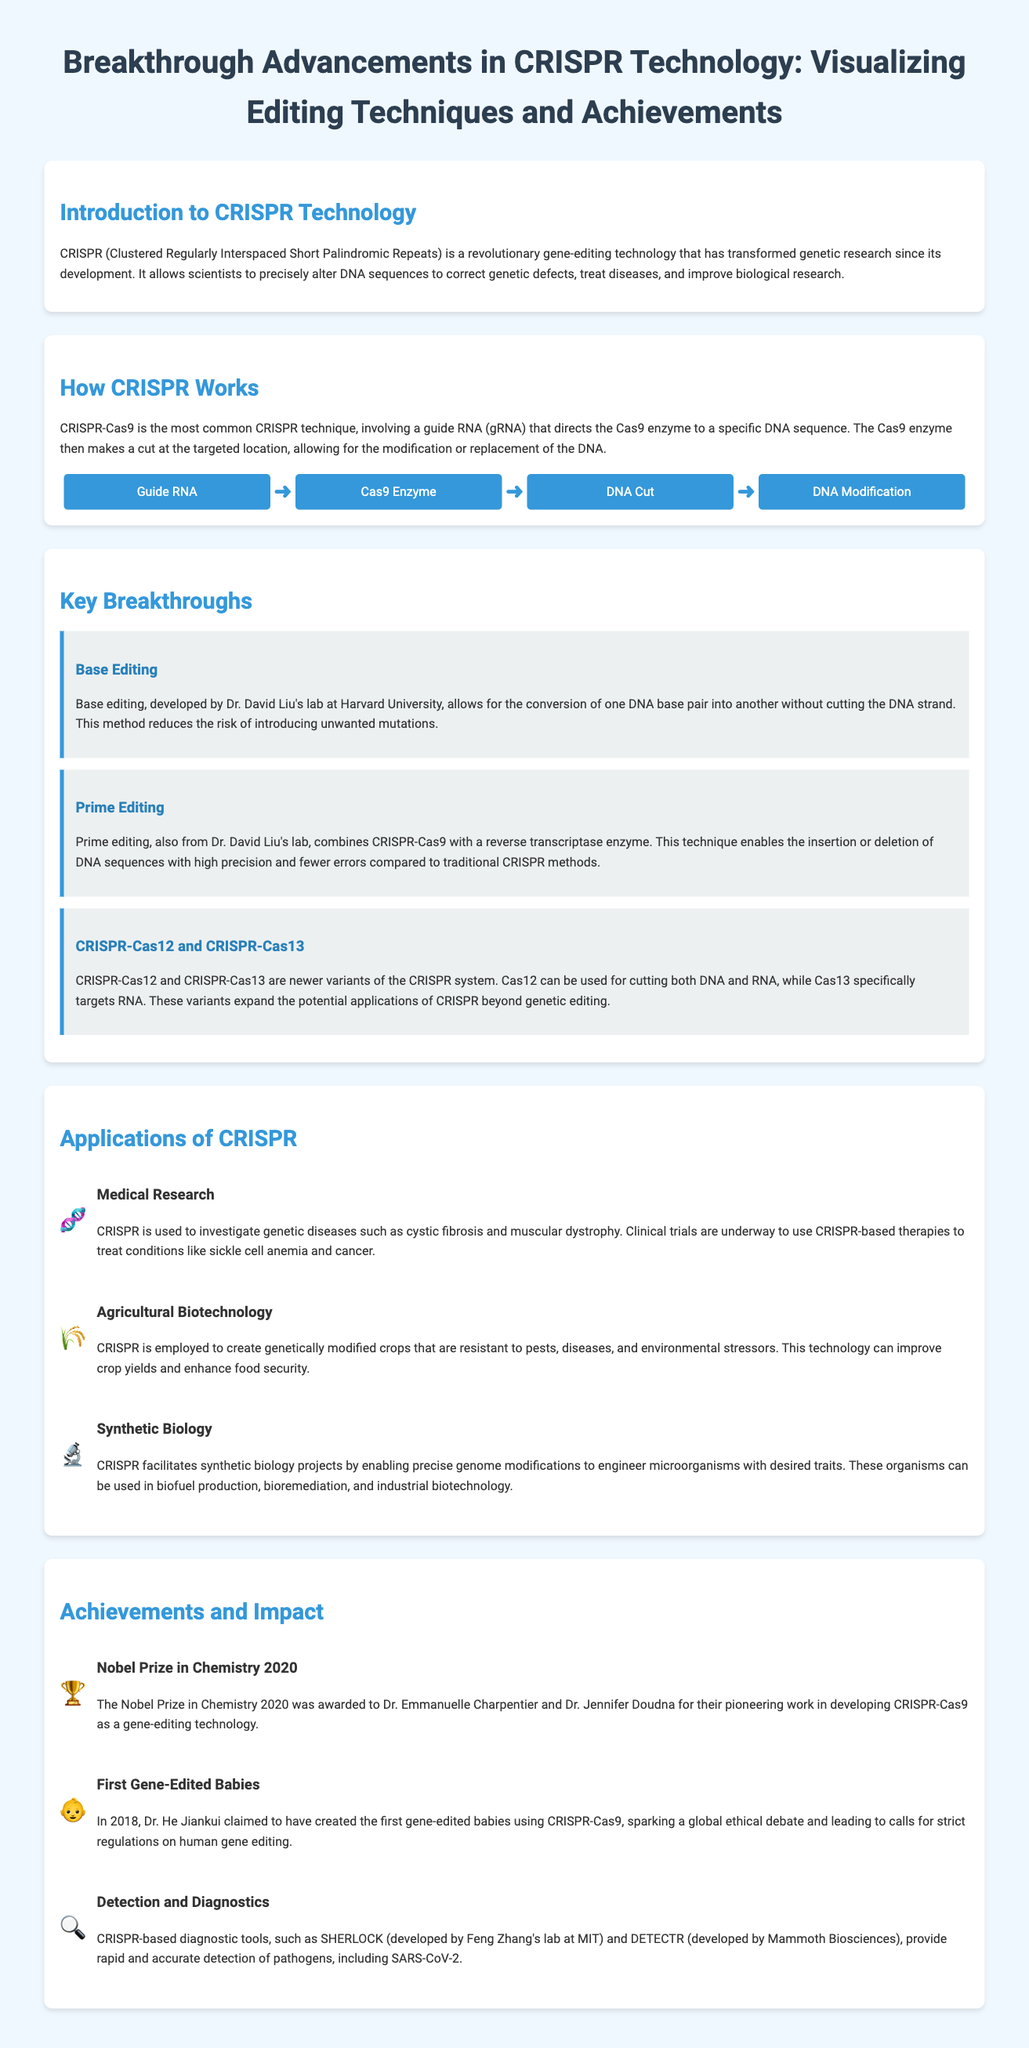What does CRISPR stand for? The document provides the full form of CRISPR in the introduction section, which is "Clustered Regularly Interspaced Short Palindromic Repeats."
Answer: Clustered Regularly Interspaced Short Palindromic Repeats Who developed base editing? The document states that base editing was developed by Dr. David Liu's lab at Harvard University.
Answer: Dr. David Liu What is the main advantage of base editing? The document mentions that base editing allows for the conversion of one DNA base pair into another without cutting the DNA strand, reducing the risk of mutations.
Answer: Reduces the risk of unwanted mutations What year was the Nobel Prize in Chemistry awarded for CRISPR-Cas9? The document states that the Nobel Prize in Chemistry was awarded in 2020 for the CRISPR-Cas9 development.
Answer: 2020 What technique combines CRISPR-Cas9 with a reverse transcriptase enzyme? The document refers to a new technique as "Prime editing."
Answer: Prime editing Which crop-related application does CRISPR technology facilitate? The document indicates that CRISPR is employed to create genetically modified crops resistant to pests and diseases.
Answer: Genetically modified crops What sparked a global ethical debate regarding gene editing? The document highlights that the creation of the first gene-edited babies claimed by Dr. He Jiankui in 2018 initiated this debate.
Answer: Gene-edited babies What is SHERLOCK? The document describes SHERLOCK as a CRISPR-based diagnostic tool for detecting pathogens.
Answer: A diagnostic tool How does the flow chart illustrate CRISPR's functioning? The flow chart visually represents the sequence of steps: Guide RNA ➜ Cas9 Enzyme ➜ DNA Cut ➜ DNA Modification.
Answer: Guide RNA, Cas9, DNA Cut, DNA Modification 